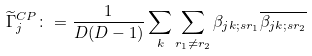<formula> <loc_0><loc_0><loc_500><loc_500>\widetilde { \Gamma } _ { j } ^ { C P } \colon = \frac { 1 } { D ( D - 1 ) } \sum _ { k } \sum _ { r _ { 1 } \neq r _ { 2 } } \beta _ { j k ; s r _ { 1 } } \overline { \beta _ { j k ; s r _ { 2 } } }</formula> 